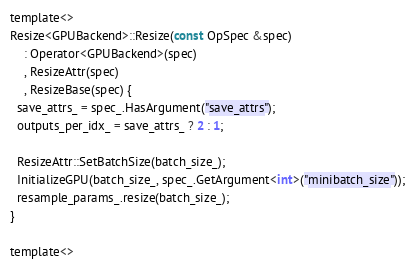<code> <loc_0><loc_0><loc_500><loc_500><_Cuda_>template<>
Resize<GPUBackend>::Resize(const OpSpec &spec)
    : Operator<GPUBackend>(spec)
    , ResizeAttr(spec)
    , ResizeBase(spec) {
  save_attrs_ = spec_.HasArgument("save_attrs");
  outputs_per_idx_ = save_attrs_ ? 2 : 1;

  ResizeAttr::SetBatchSize(batch_size_);
  InitializeGPU(batch_size_, spec_.GetArgument<int>("minibatch_size"));
  resample_params_.resize(batch_size_);
}

template<></code> 